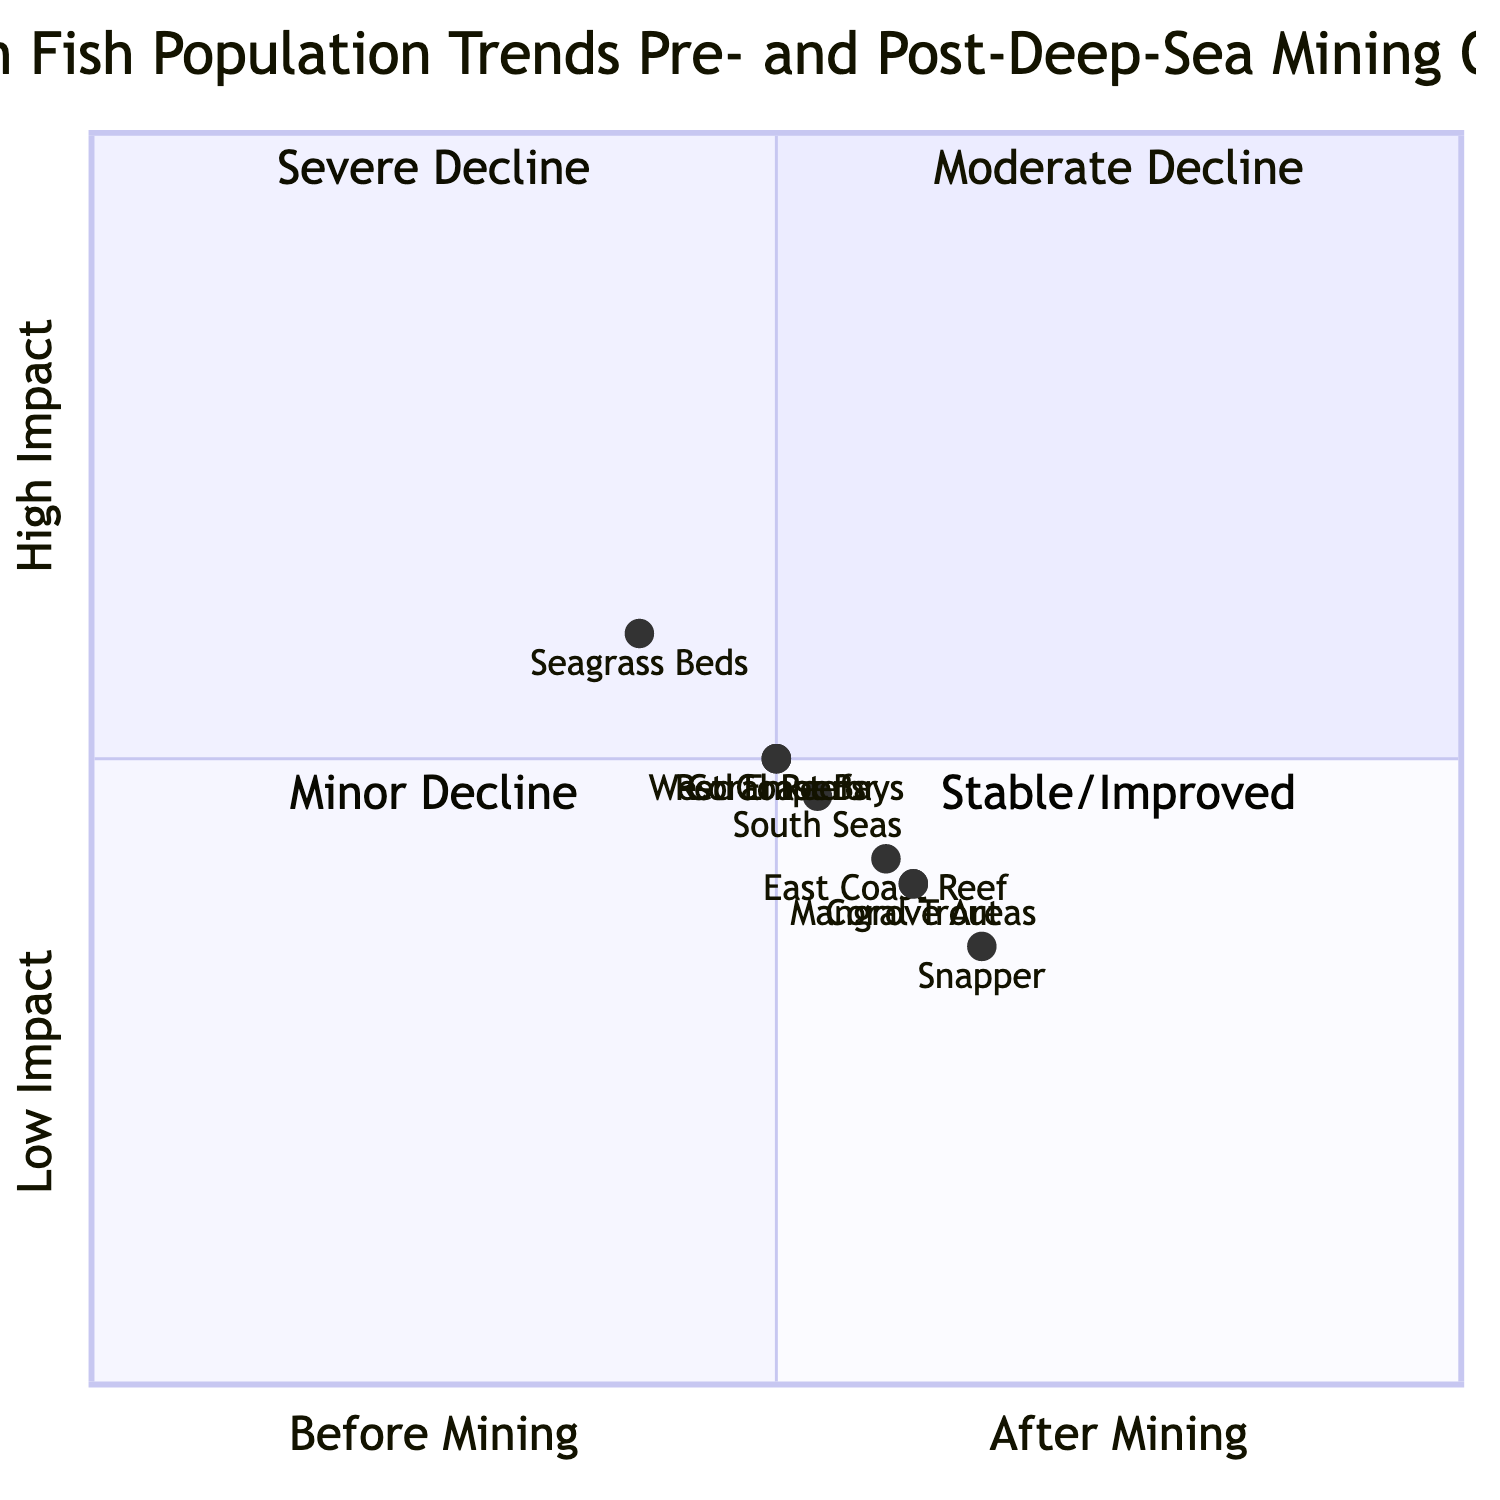What is the fish diversity for Coral Trout after mining? The diagram states that the fish diversity for Coral Trout post-mining is represented by the data point, which indicates a value of 90.
Answer: 90 What was the fish abundance for Snapper before mining? According to the diagram, the fish abundance for Snapper labeled before mining shows a value of 6000.
Answer: 6000 How many major fishing areas are represented before mining? The diagram indicates that there are three major fishing areas listed under the "Before Mining" category: East Coast Reef, West Coast Bays, and South Seas.
Answer: 3 Which major fishing area showed the greatest decline in the number of fish post-mining? By comparing the data for major fishing areas before and after mining, the East Coast Reef had a value of 12 before and dropped to 7 after mining, showing the greatest decline.
Answer: East Coast Reef Is there a decrease or increase in breeding grounds for Seagrass Beds after mining? The comparison of breeding ground values for Seagrass Beds before and after mining shows a decrease from 25 to 10. Therefore, it indicates a decrease.
Answer: Decrease What quadrant does the Coral Trout fall into based on the diagram? The Coral Trout shows a trend from a higher value of 150 (pre-mining) to a lower value of 90 (post-mining), placing it in the quadrant that signifies a moderate decline.
Answer: Moderate Decline What is the highest value for fish abundance after mining? Evaluating the fish abundance post-mining data, Snapper has the highest value at 3800.
Answer: 3800 Which fish species had the smallest decline in diversity? By comparing the diversity values pre- and post-mining, Red Emperor shows the smallest decline, reducing from 120 to 60.
Answer: Red Emperor 